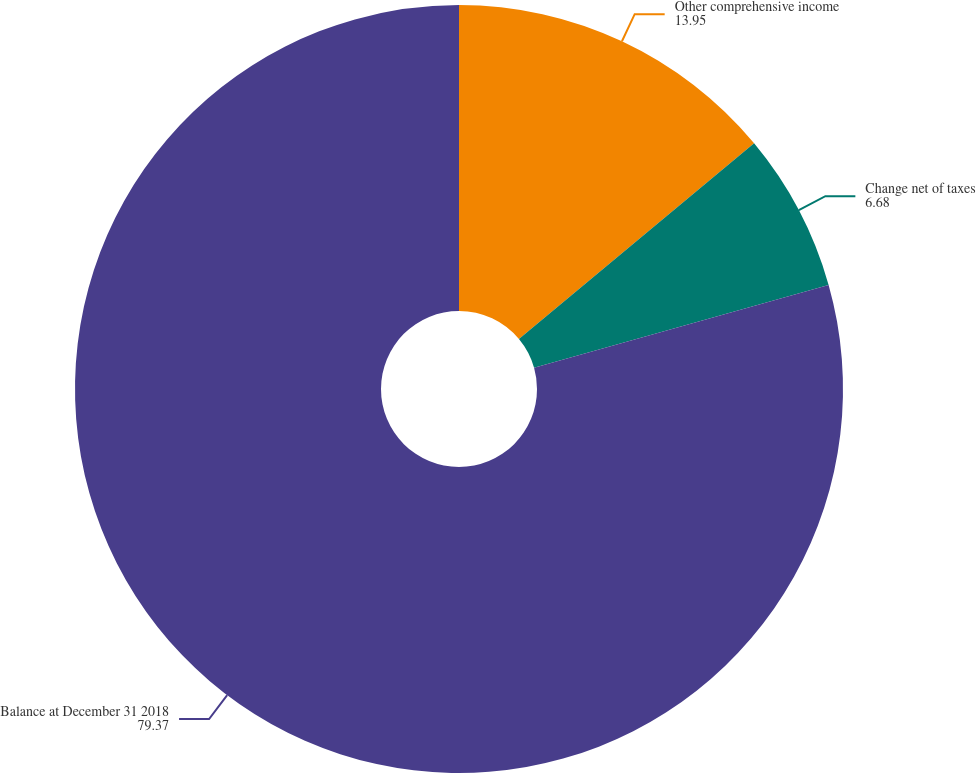Convert chart. <chart><loc_0><loc_0><loc_500><loc_500><pie_chart><fcel>Other comprehensive income<fcel>Change net of taxes<fcel>Balance at December 31 2018<nl><fcel>13.95%<fcel>6.68%<fcel>79.37%<nl></chart> 